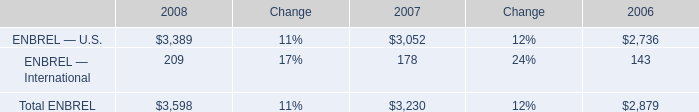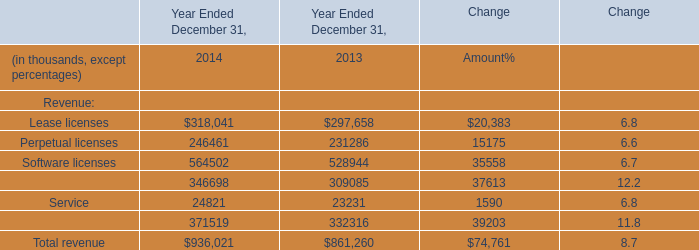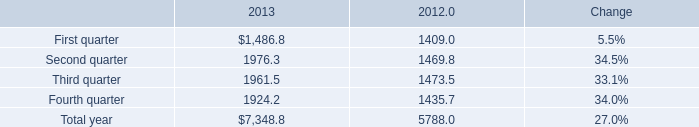What is the growing rate of Maintenancein in the year with the most Service? 
Computations: ((346698 - 309085) / 309085)
Answer: 0.12169. 